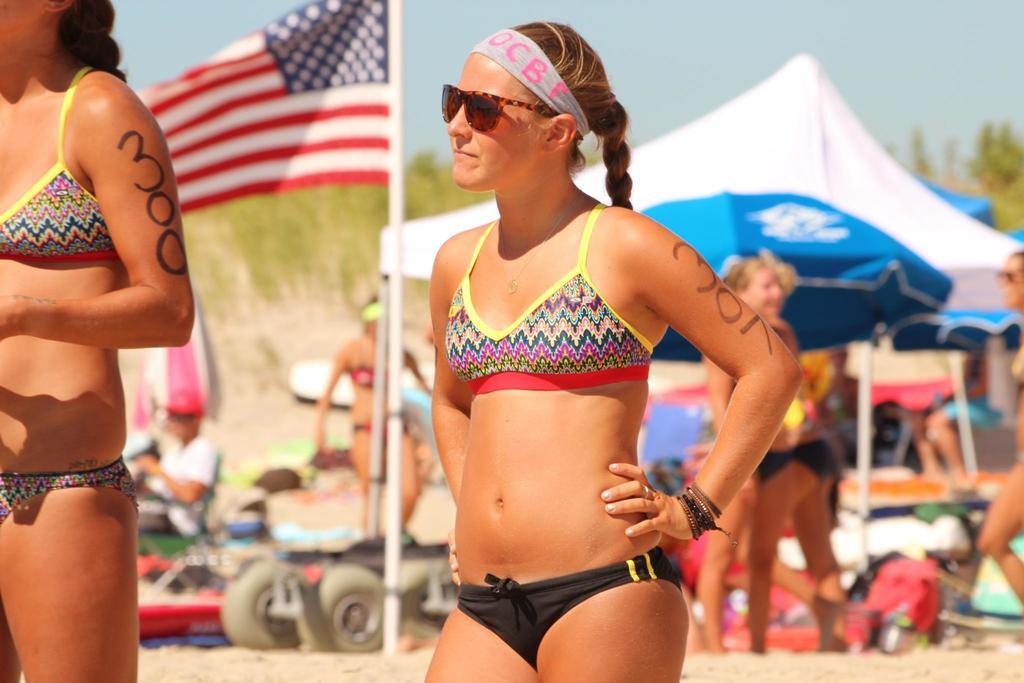What are the women in the image wearing? There are women in bikinis in the image. What can be seen on the right side of the image? There is a tent on the right side of the image, with white and blue colors. What is located in the middle of the image? There is a flag in the middle of the image. What is visible at the top of the image? The sky is visible at the top of the image. What type of food is being cooked in the oven in the image? There is no oven present in the image. How many balls are visible in the image? There are no balls visible in the image. 